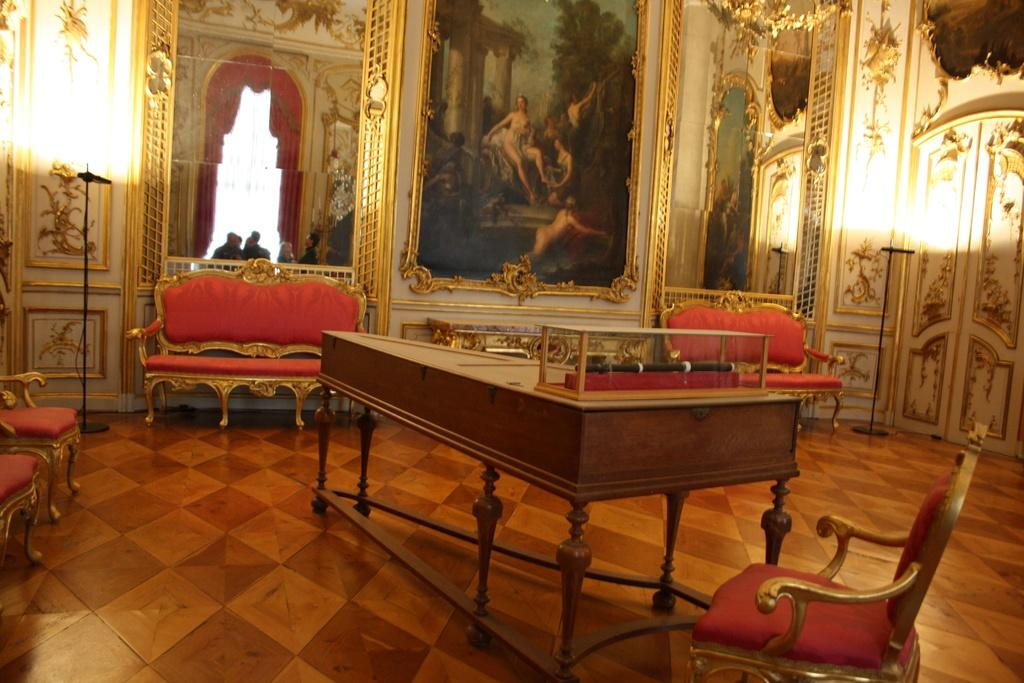What is the setting of the image? The image is inside a room. What type of furniture is present in the room? There are chairs and sofas on the floor. Are there any decorative items on the walls? Yes, there is a photo frame on the wall. What is another reflective surface present in the room? There is a mirror in the room. Can you describe what is visible through the mirror? Few people are seen through the mirror. What type of kick is being performed by the dad in the image? There is no dad or kick present in the image. 